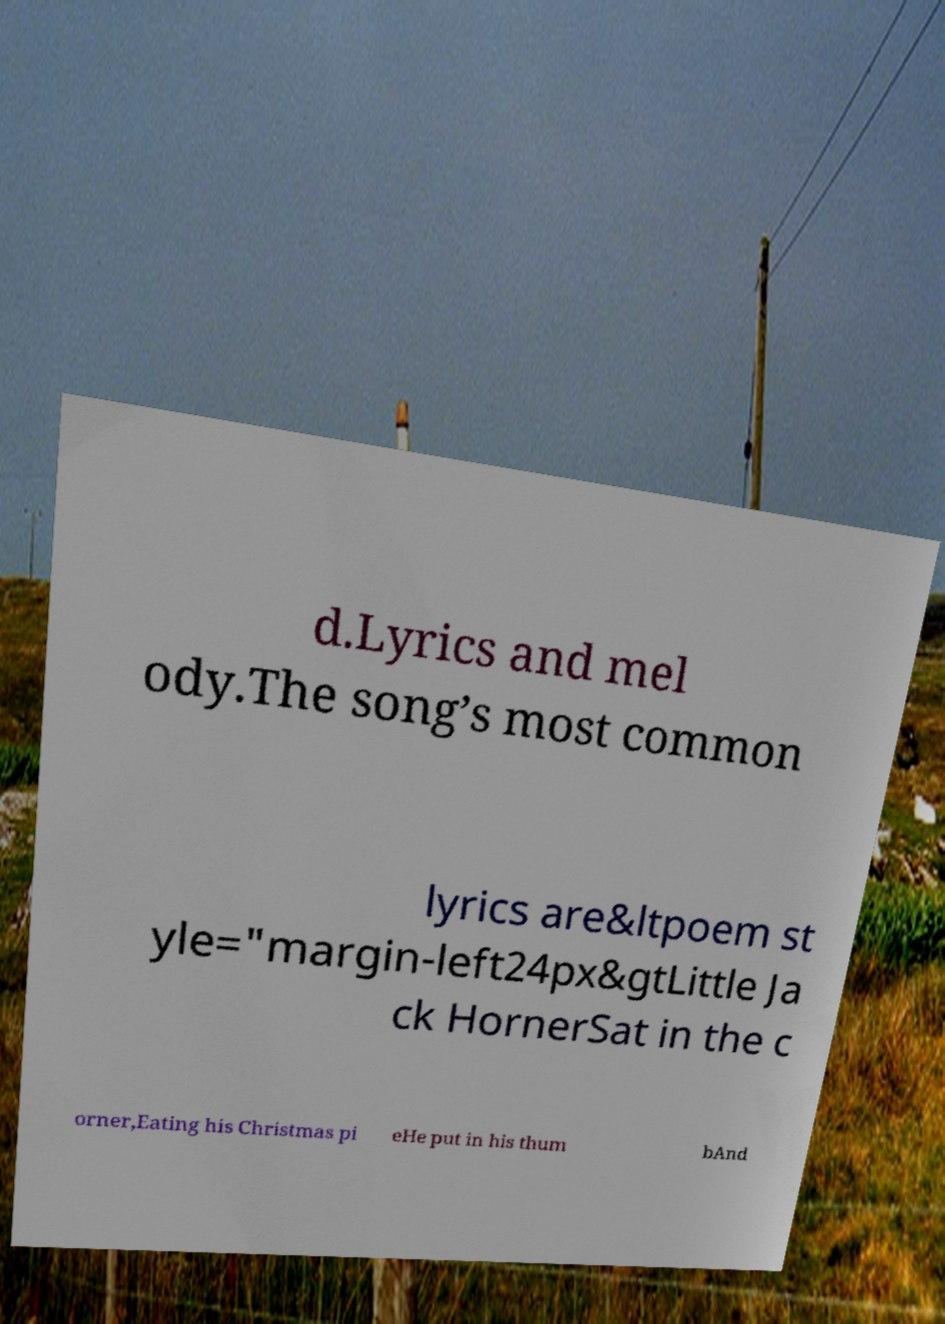Can you accurately transcribe the text from the provided image for me? d.Lyrics and mel ody.The song’s most common lyrics are&ltpoem st yle="margin-left24px&gtLittle Ja ck HornerSat in the c orner,Eating his Christmas pi eHe put in his thum bAnd 